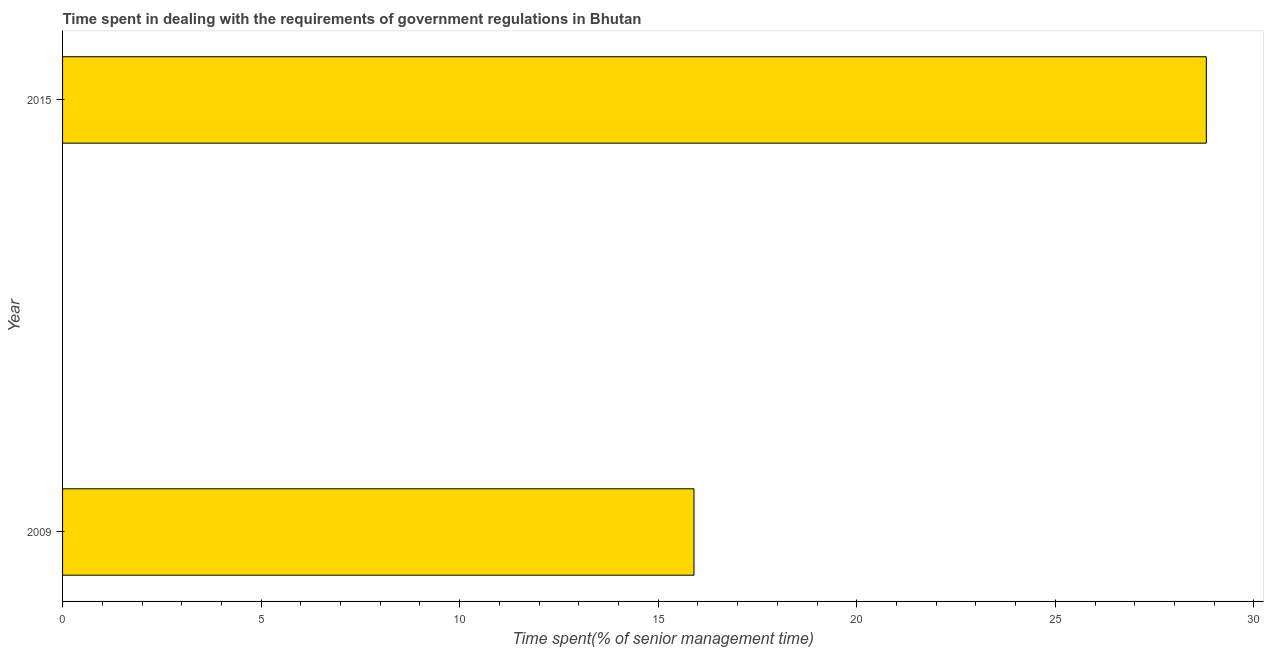Does the graph contain any zero values?
Your answer should be very brief. No. What is the title of the graph?
Ensure brevity in your answer.  Time spent in dealing with the requirements of government regulations in Bhutan. What is the label or title of the X-axis?
Ensure brevity in your answer.  Time spent(% of senior management time). What is the label or title of the Y-axis?
Give a very brief answer. Year. What is the time spent in dealing with government regulations in 2015?
Your response must be concise. 28.8. Across all years, what is the maximum time spent in dealing with government regulations?
Make the answer very short. 28.8. Across all years, what is the minimum time spent in dealing with government regulations?
Give a very brief answer. 15.9. In which year was the time spent in dealing with government regulations maximum?
Provide a succinct answer. 2015. What is the sum of the time spent in dealing with government regulations?
Keep it short and to the point. 44.7. What is the difference between the time spent in dealing with government regulations in 2009 and 2015?
Offer a very short reply. -12.9. What is the average time spent in dealing with government regulations per year?
Provide a succinct answer. 22.35. What is the median time spent in dealing with government regulations?
Make the answer very short. 22.35. What is the ratio of the time spent in dealing with government regulations in 2009 to that in 2015?
Provide a succinct answer. 0.55. Is the time spent in dealing with government regulations in 2009 less than that in 2015?
Provide a succinct answer. Yes. Are all the bars in the graph horizontal?
Provide a short and direct response. Yes. How many years are there in the graph?
Make the answer very short. 2. What is the difference between two consecutive major ticks on the X-axis?
Offer a very short reply. 5. What is the Time spent(% of senior management time) of 2015?
Provide a succinct answer. 28.8. What is the ratio of the Time spent(% of senior management time) in 2009 to that in 2015?
Make the answer very short. 0.55. 